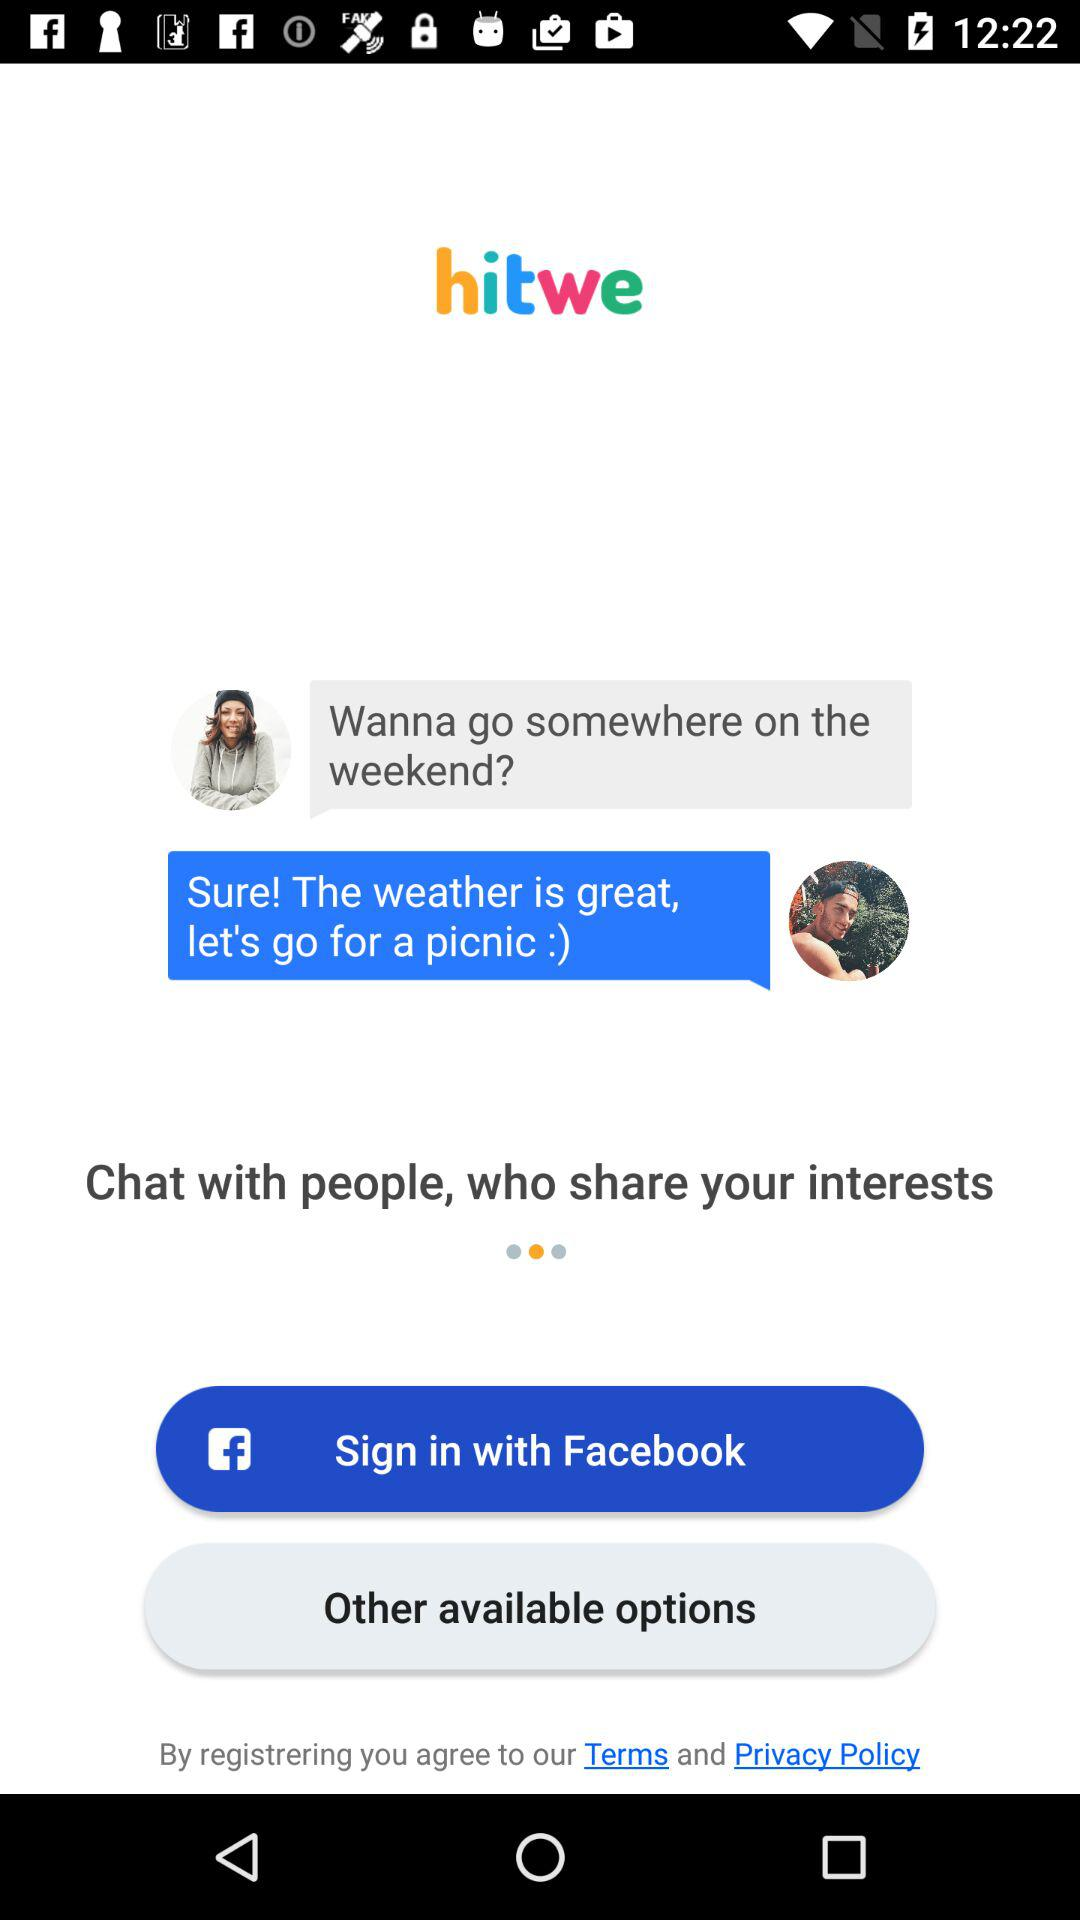What application can be used to sign in? The application that can be used to sign in is "Facebook". 